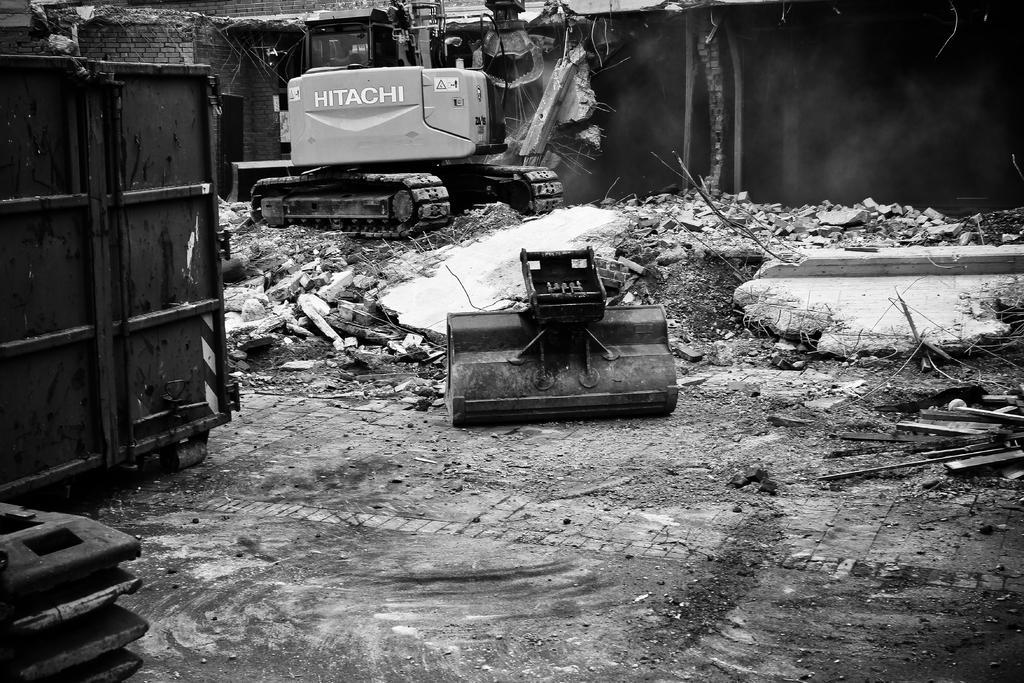In one or two sentences, can you explain what this image depicts? This is black and white image, in this image there is a crane, in the background there are buildings that are destroyed. 